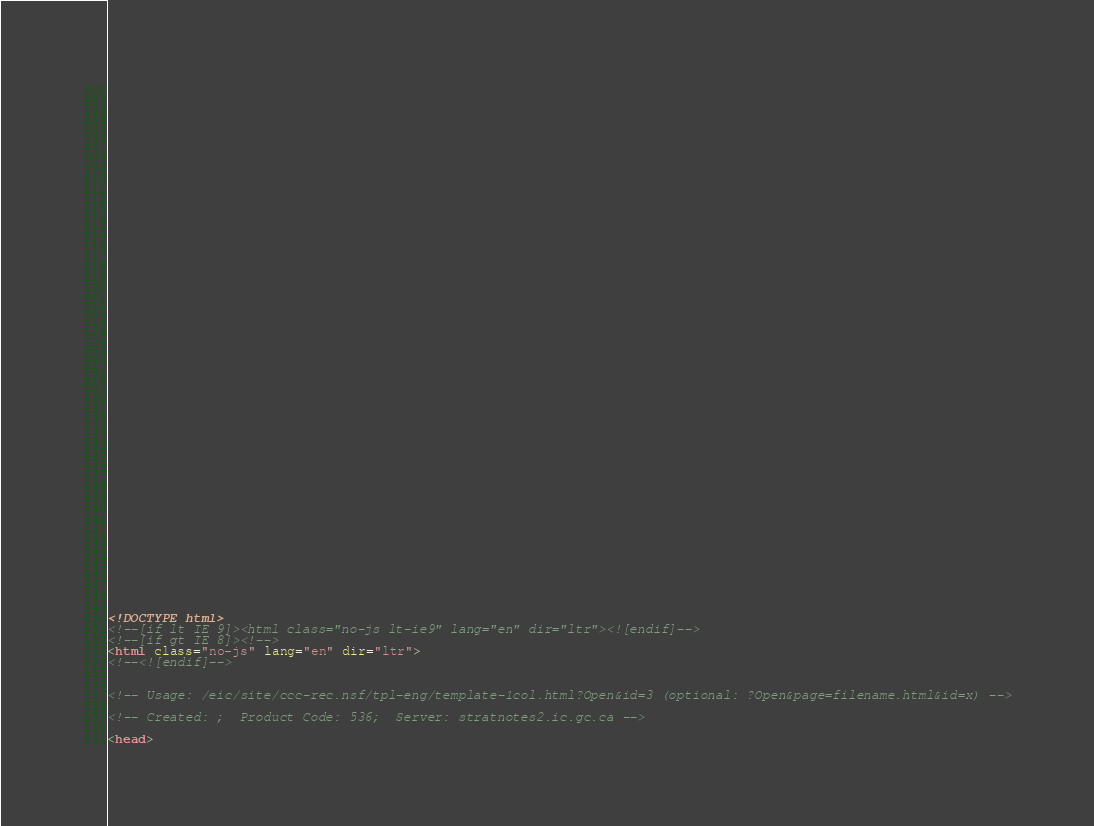Convert code to text. <code><loc_0><loc_0><loc_500><loc_500><_HTML_>


















	






  
  
  
  































	
	
	



<!DOCTYPE html>
<!--[if lt IE 9]><html class="no-js lt-ie9" lang="en" dir="ltr"><![endif]-->
<!--[if gt IE 8]><!-->
<html class="no-js" lang="en" dir="ltr">
<!--<![endif]-->


<!-- Usage: /eic/site/ccc-rec.nsf/tpl-eng/template-1col.html?Open&id=3 (optional: ?Open&page=filename.html&id=x) -->

<!-- Created: ;  Product Code: 536;  Server: stratnotes2.ic.gc.ca -->

<head></code> 